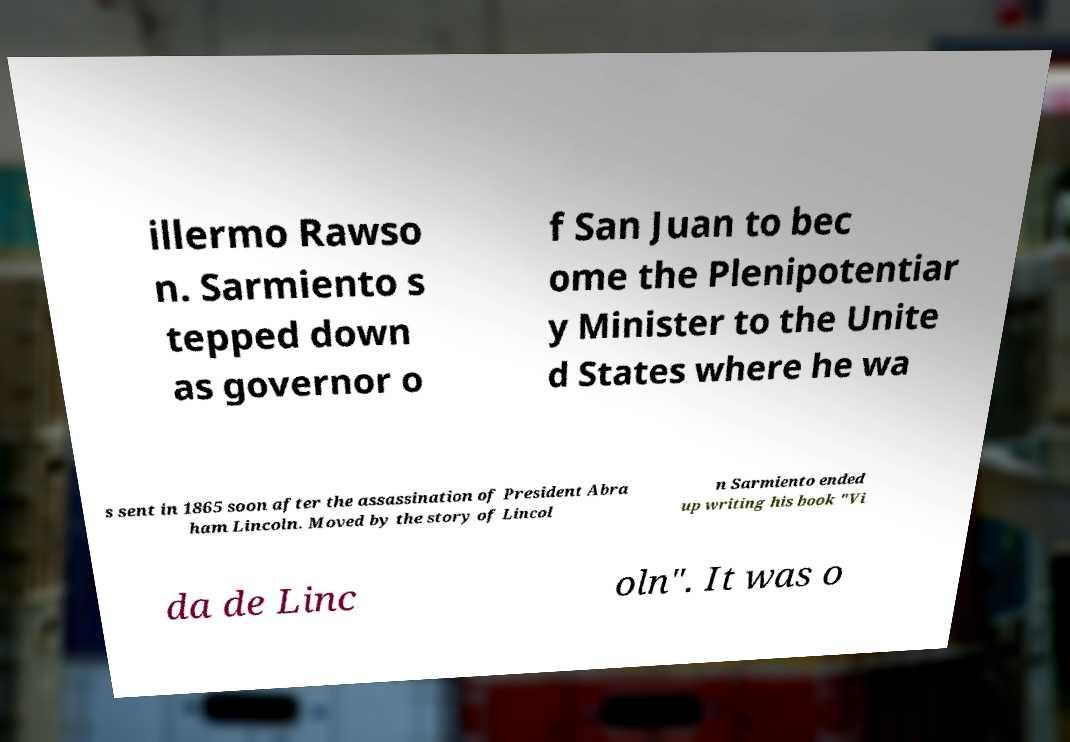Could you extract and type out the text from this image? illermo Rawso n. Sarmiento s tepped down as governor o f San Juan to bec ome the Plenipotentiar y Minister to the Unite d States where he wa s sent in 1865 soon after the assassination of President Abra ham Lincoln. Moved by the story of Lincol n Sarmiento ended up writing his book "Vi da de Linc oln". It was o 